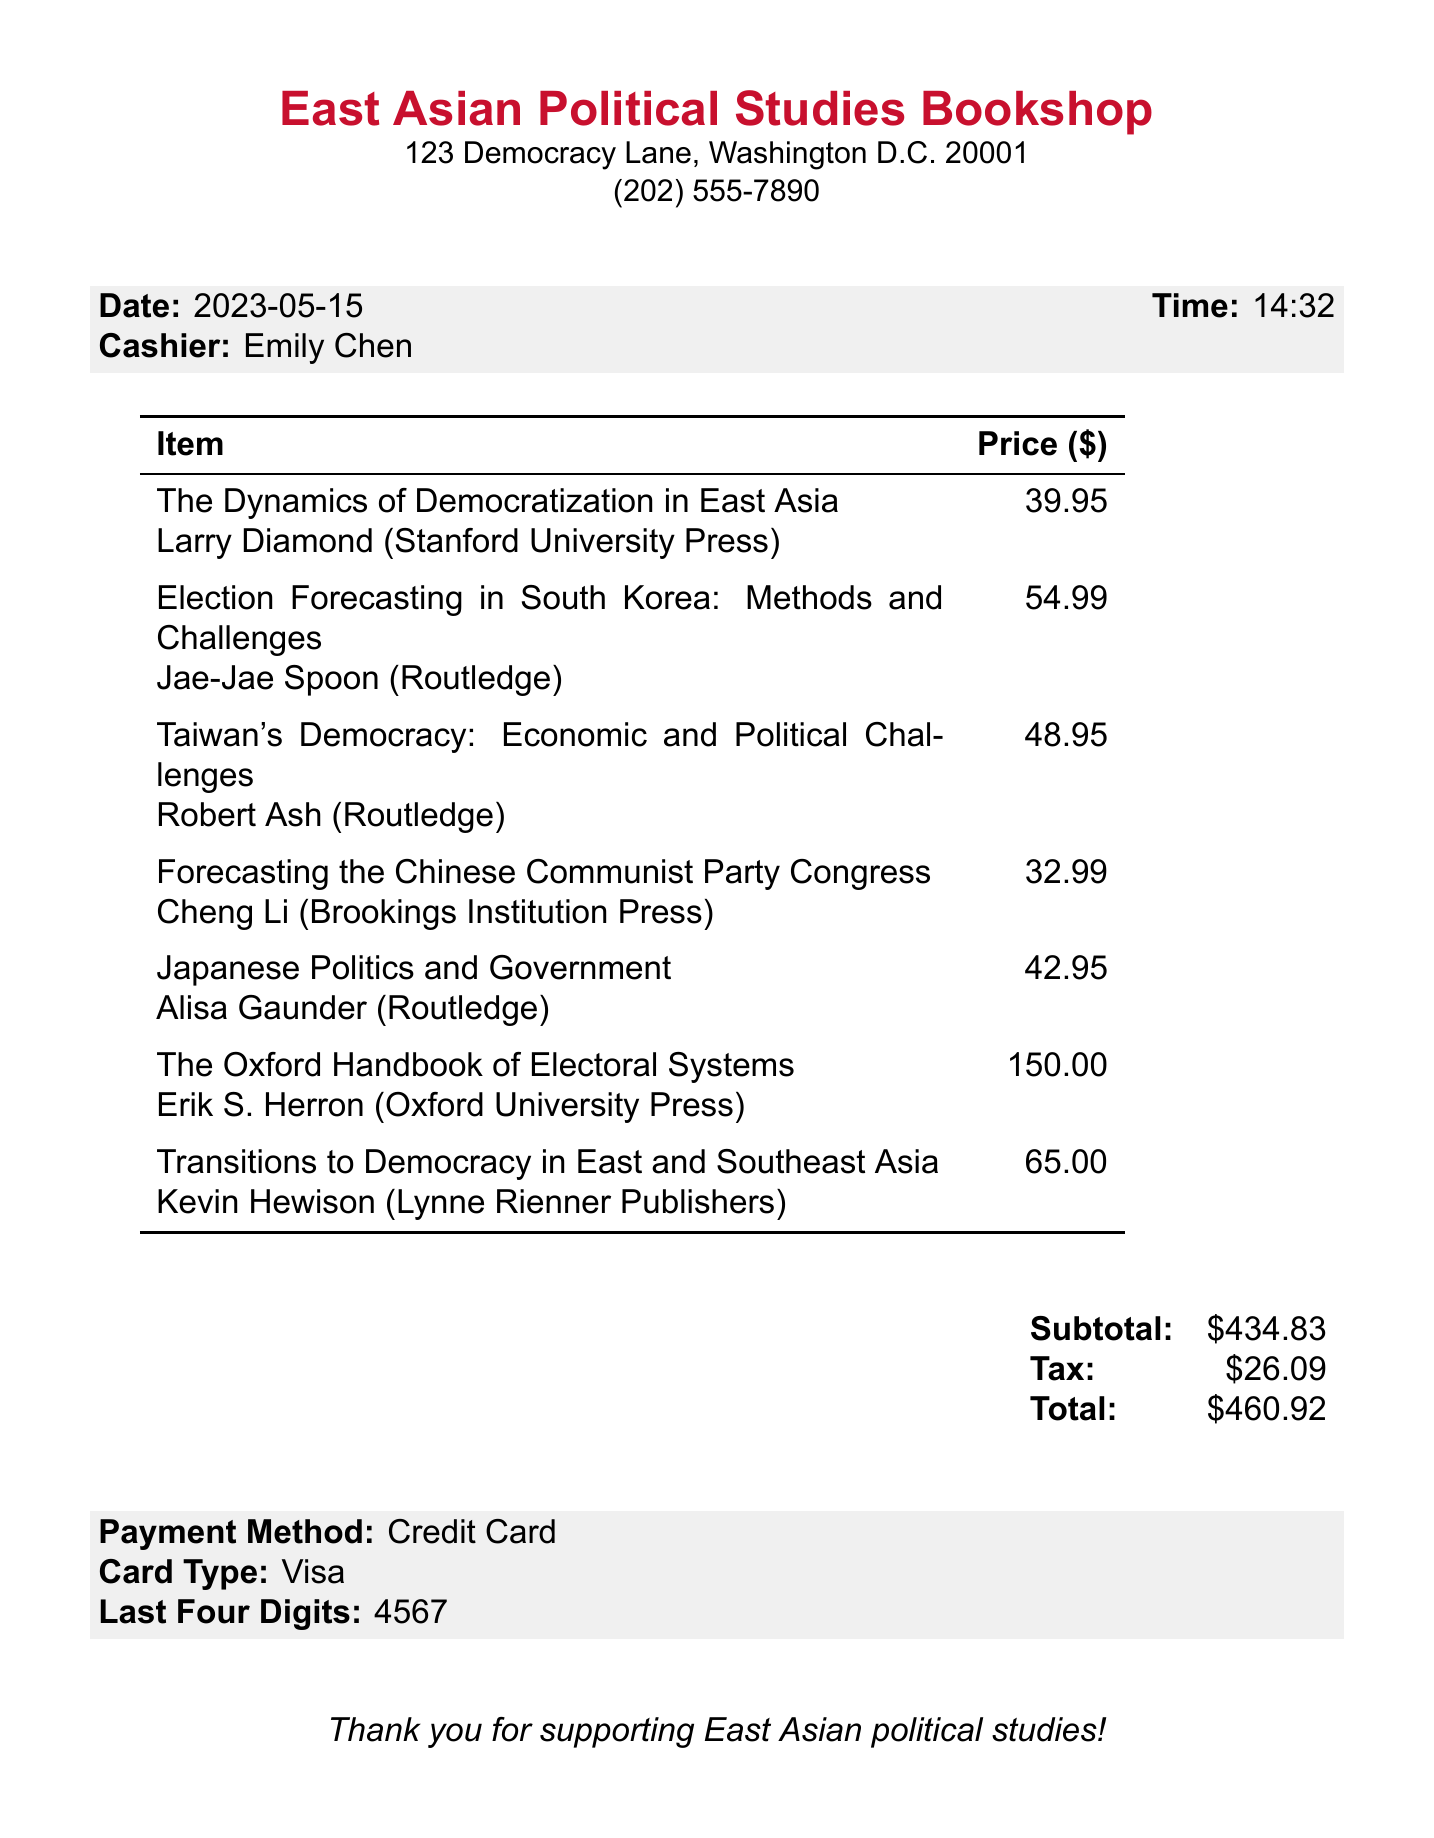What is the name of the bookstore? The name of the bookstore is explicitly listed at the top of the document.
Answer: East Asian Political Studies Bookshop Who was the cashier at the time of purchase? The cashier's name is stated in the receipt section under cashier details.
Answer: Emily Chen What is the date of the purchase? The date is clearly noted in the document, indicating when the transaction occurred.
Answer: 2023-05-15 How many items were purchased? By counting the listed items in the document, the total number can be determined.
Answer: 7 What is the price of "The Oxford Handbook of Electoral Systems"? The price for this specific title is recorded next to it in the list of items.
Answer: 150.00 What is the total amount charged on the receipt? The total amount is summarized at the end of the receipt, representing the final charge.
Answer: 460.92 What type of card was used for payment? The type of card is included in the payment information section at the bottom of the document.
Answer: Visa What is the subtotal before tax? The subtotal is calculated and clearly displayed in the summary section of the receipt.
Answer: 434.83 Who is the author of "Election Forecasting in South Korea: Methods and Challenges"? The author's name is stated directly after the title of the book in the receipt.
Answer: Jae-Jae Spoon 